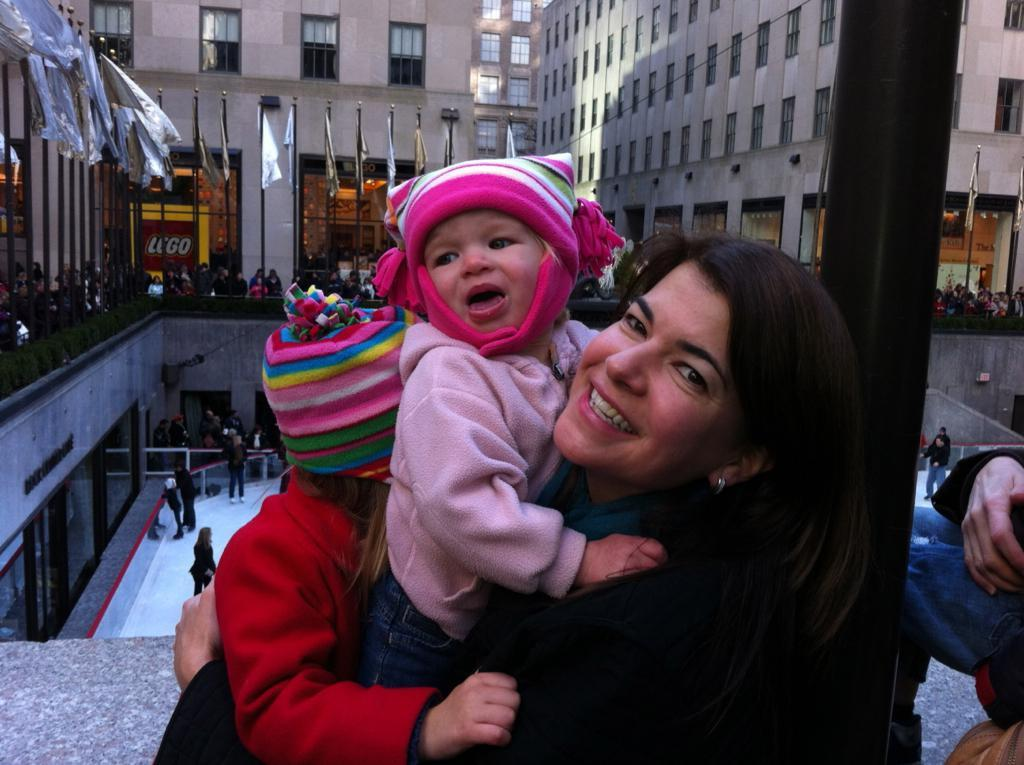Who is the main subject in the image? There is a woman in the image. What is the woman doing in the image? The woman is carrying children. What can be seen in the background of the image? There are people, flags, a pole, buildings, and other objects in the background of the image. Can you see a toad hopping near the river in the image? There is no river or toad present in the image. What type of tiger can be seen in the background of the image? There is no tiger present in the image. 